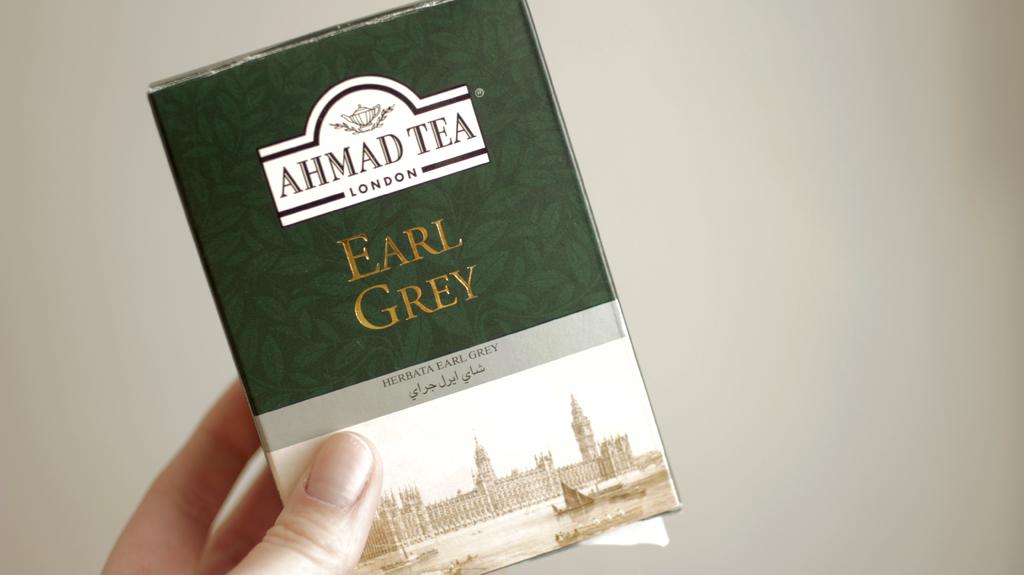Where was this tea made?
Provide a short and direct response. London. Which flavor of tea is in the package?
Offer a very short reply. Earl grey. 